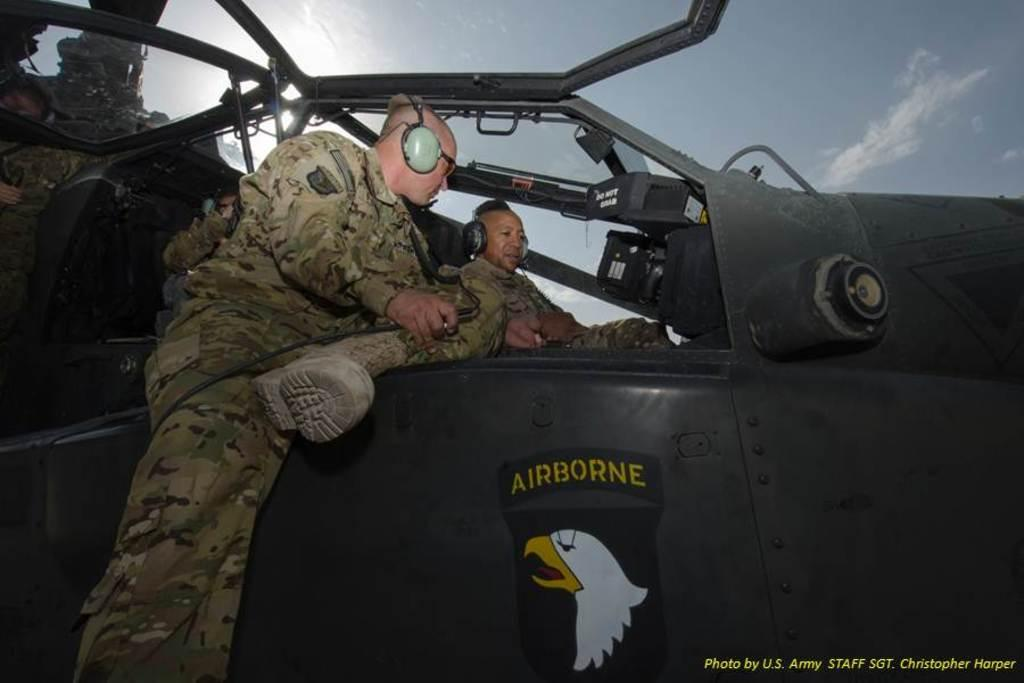<image>
Describe the image concisely. Two pilots chatting in a cockpit with "airborne" written on the side. 